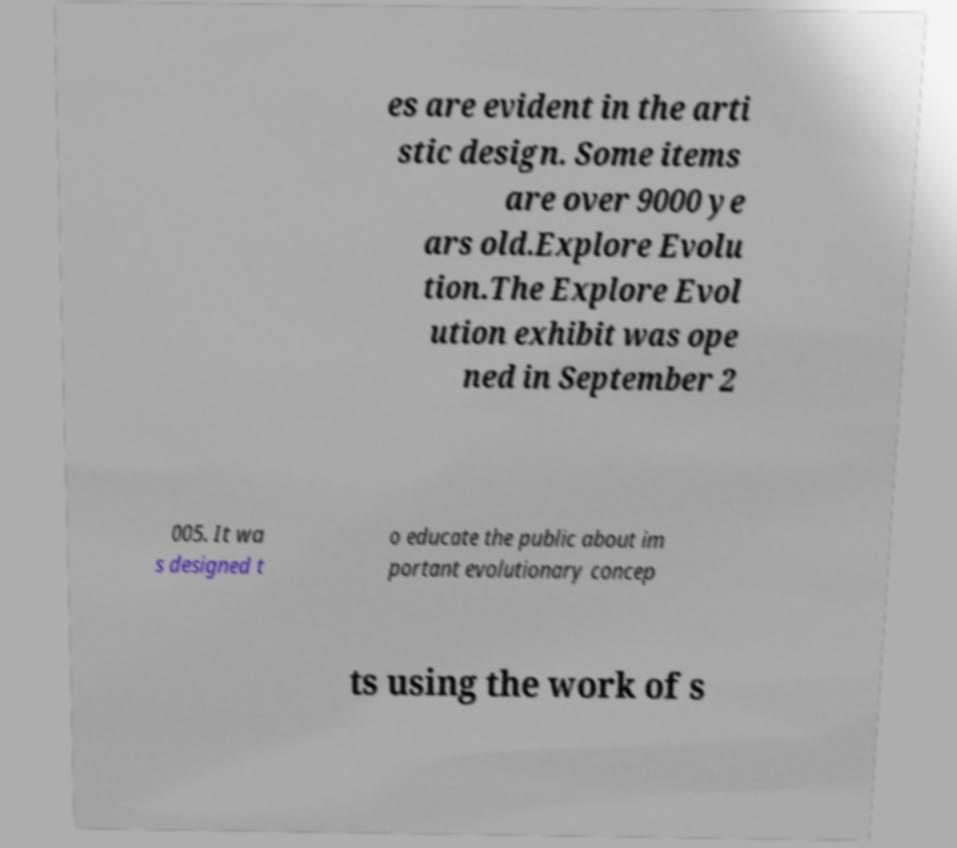There's text embedded in this image that I need extracted. Can you transcribe it verbatim? es are evident in the arti stic design. Some items are over 9000 ye ars old.Explore Evolu tion.The Explore Evol ution exhibit was ope ned in September 2 005. It wa s designed t o educate the public about im portant evolutionary concep ts using the work of s 